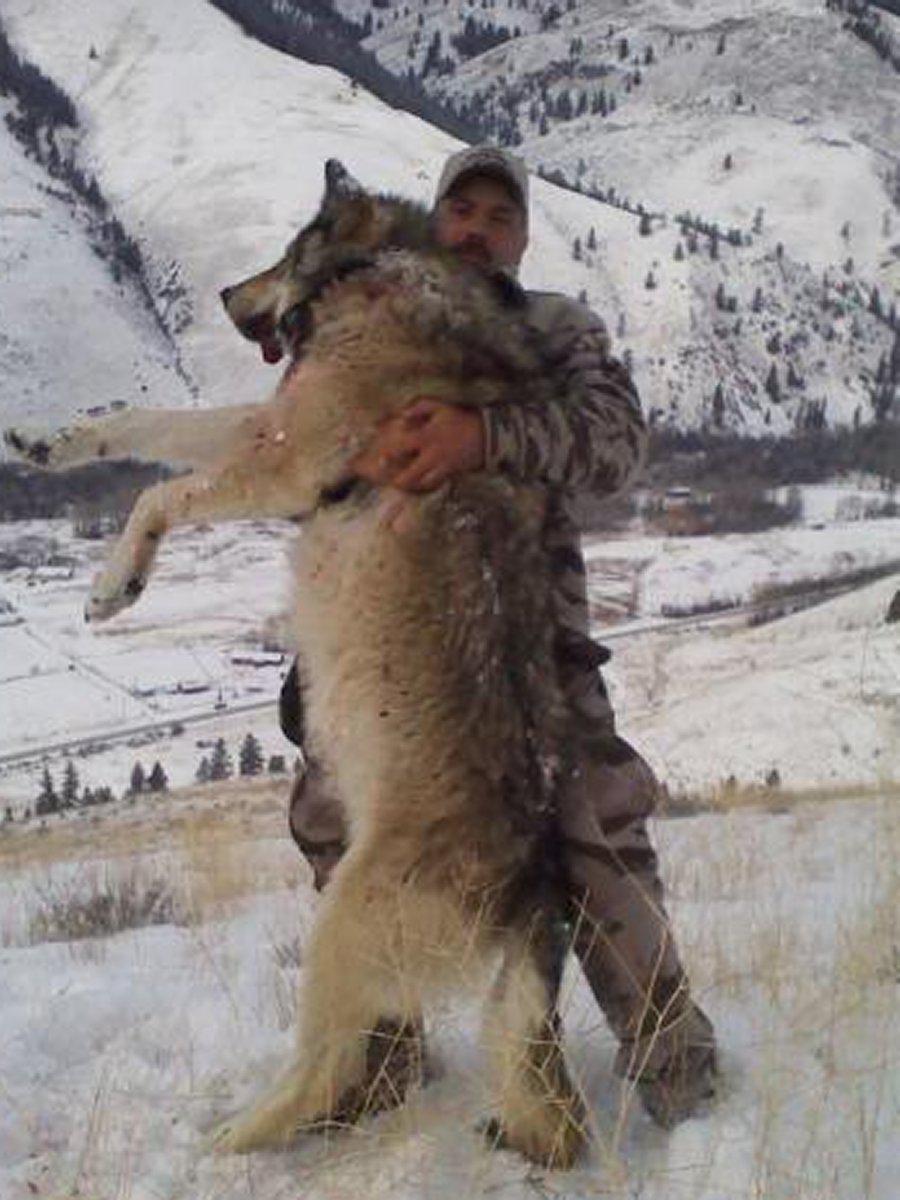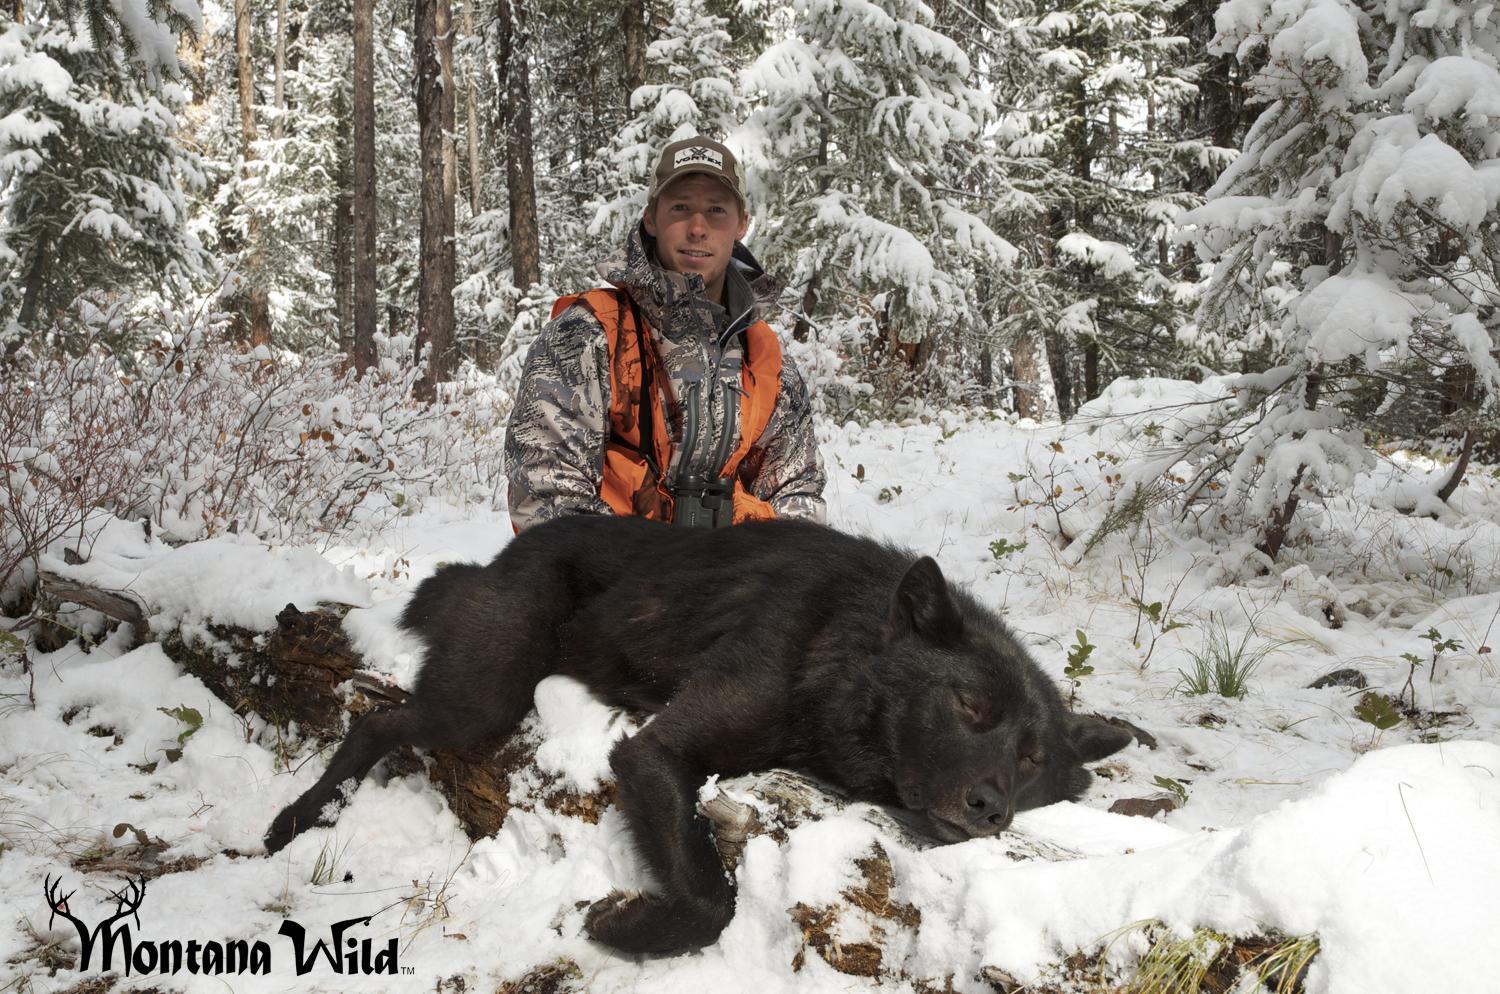The first image is the image on the left, the second image is the image on the right. Examine the images to the left and right. Is the description "There are no more than two wolves." accurate? Answer yes or no. Yes. 